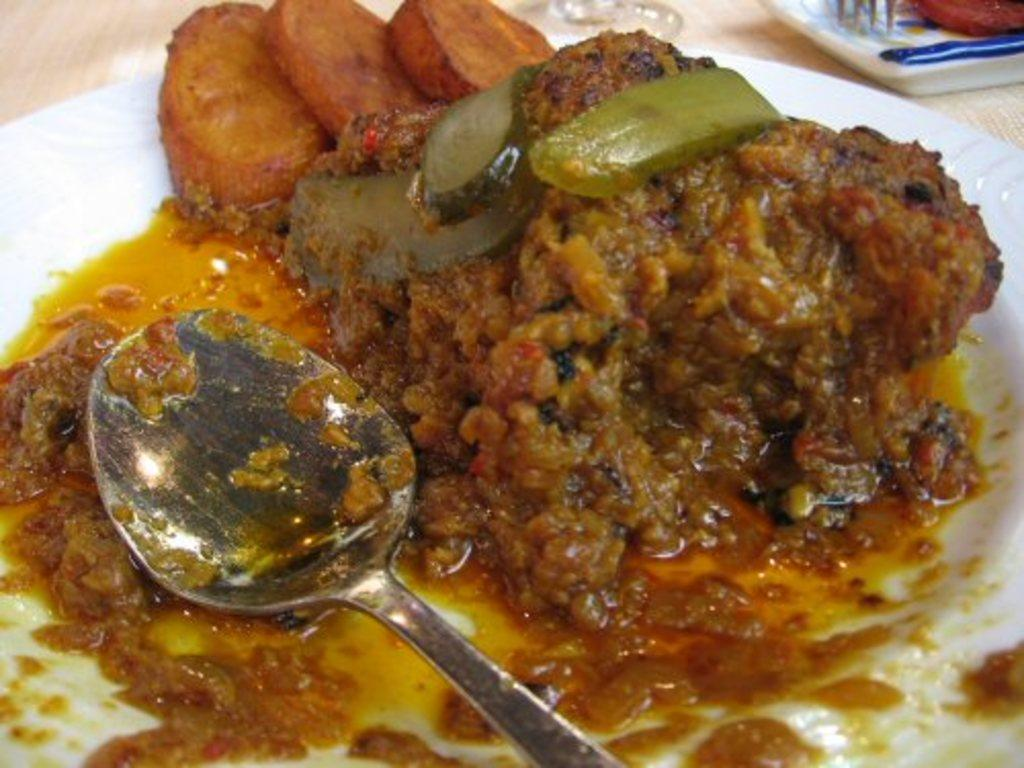What is on the white plate in the image? There is food on a white plate in the image. What utensil is placed with the food on the plate? There is a spoon on the plate. What can be used for wiping or blowing one's nose in the image? Tissues are visible in the image. What other utensil is present in the image? There is a fork in the image. Where is the scene in the image likely taking place? The image appears to be set on a table, or at least near, a table. What type of bean is the manager discussing with the carpenter in the image? There is no bean, manager, or carpenter present in the image; it features food on a plate with utensils and tissues. 